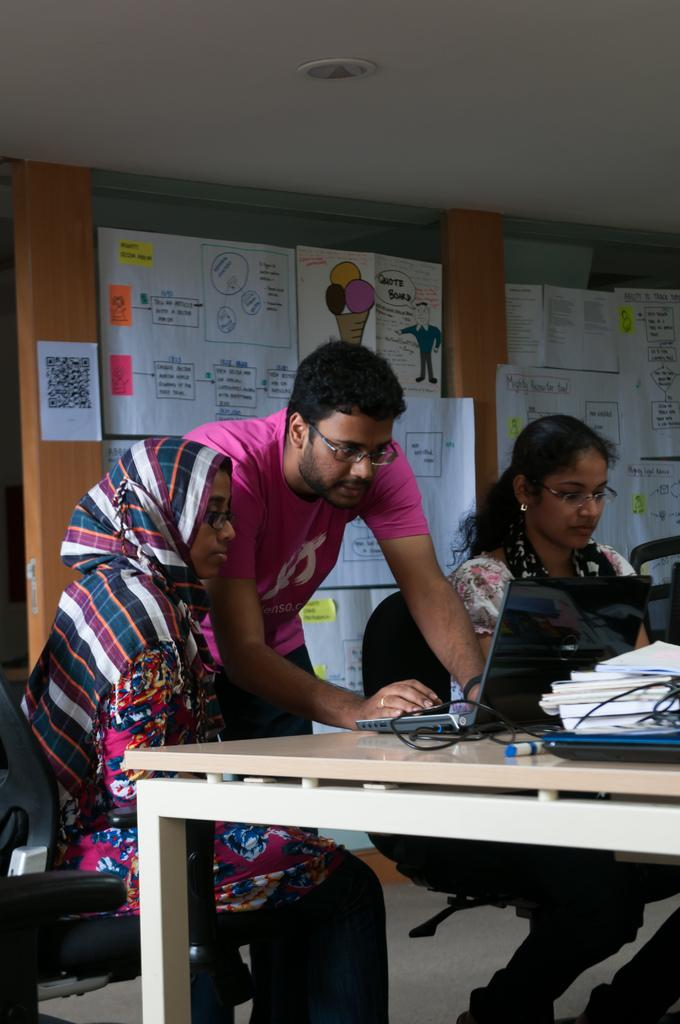How many people are present in the image? There are three people in the image. What is the woman in the image doing? The woman is sitting on a chair. What objects can be seen on the table in the image? There is a laptop, a marker, and a book on the table. What is visible on the glass at the backside? There are charts on the glass at the backside. What type of cable is being used to connect the laptop to the summer in the image? There is no cable or reference to summer present in the image. 